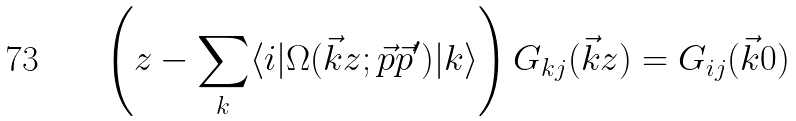Convert formula to latex. <formula><loc_0><loc_0><loc_500><loc_500>\left ( z - \sum _ { k } \langle i | \Omega ( \vec { k } z ; \vec { p } \vec { p } ^ { \prime } ) | k \rangle \right ) G _ { k j } ( \vec { k } z ) = G _ { i j } ( \vec { k } 0 )</formula> 